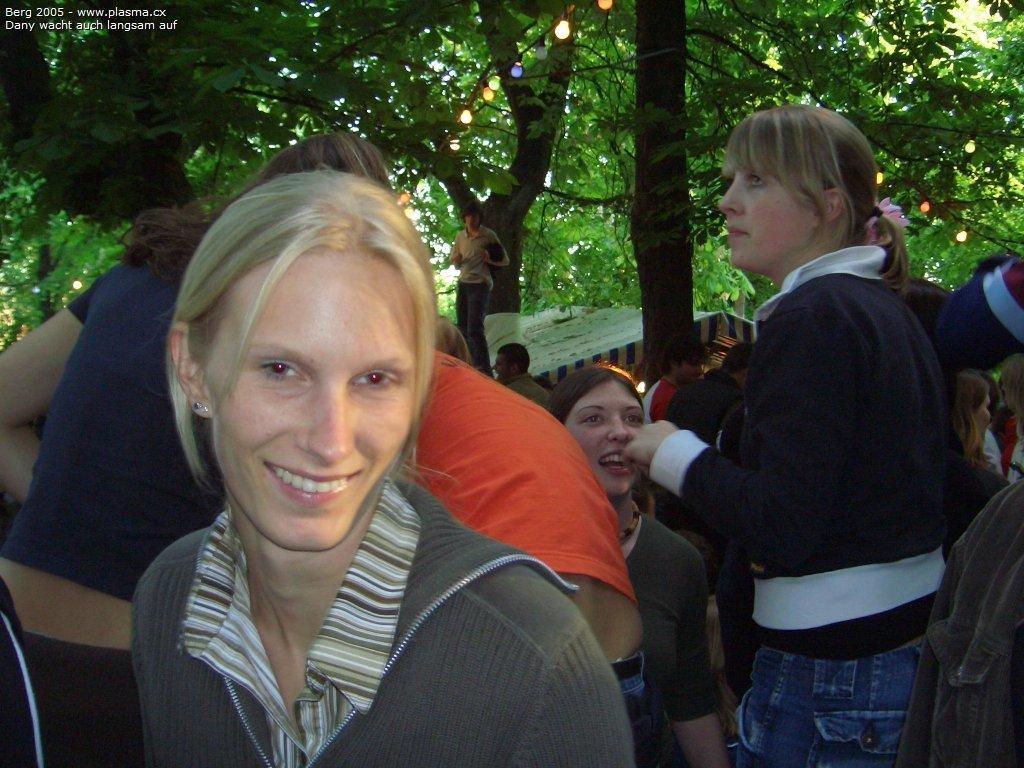Please provide a concise description of this image. In the middle of the image few women are standing and smiling. Behind them we can see some trees and tents. 